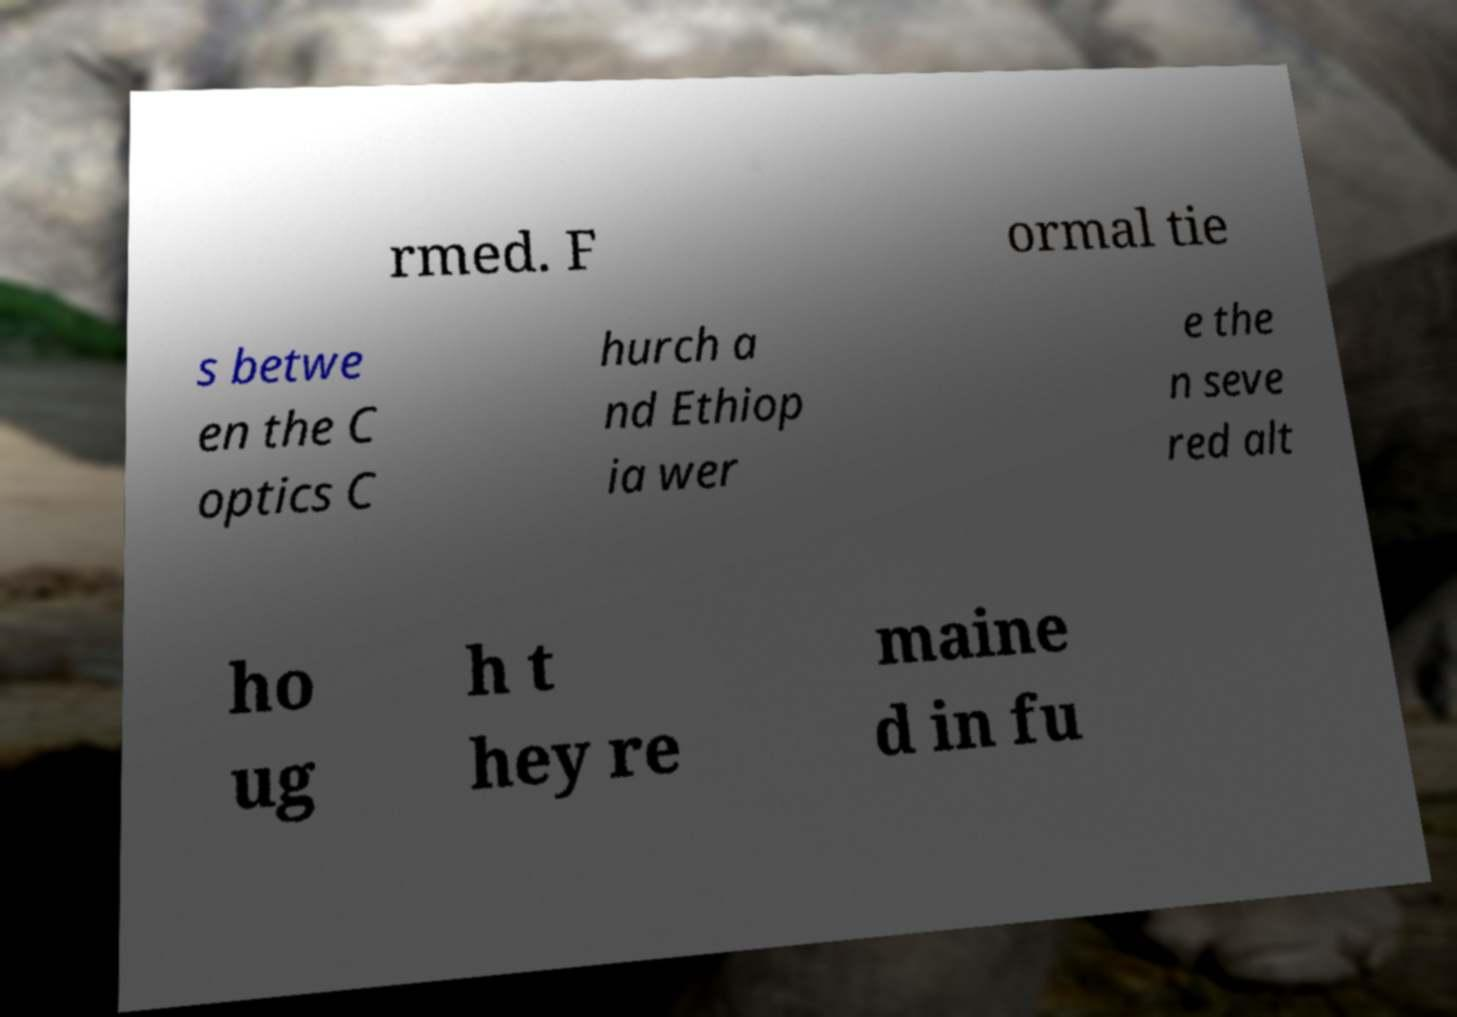Could you assist in decoding the text presented in this image and type it out clearly? rmed. F ormal tie s betwe en the C optics C hurch a nd Ethiop ia wer e the n seve red alt ho ug h t hey re maine d in fu 